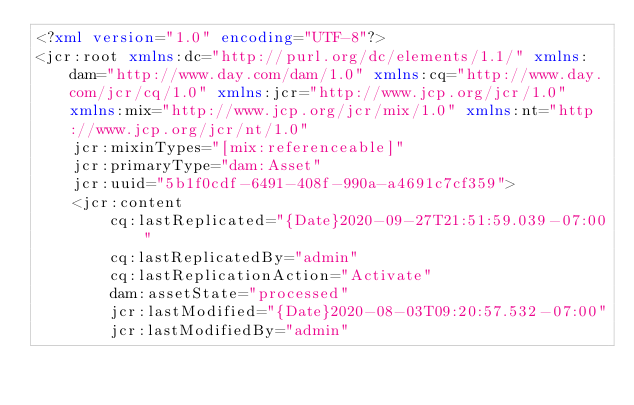<code> <loc_0><loc_0><loc_500><loc_500><_XML_><?xml version="1.0" encoding="UTF-8"?>
<jcr:root xmlns:dc="http://purl.org/dc/elements/1.1/" xmlns:dam="http://www.day.com/dam/1.0" xmlns:cq="http://www.day.com/jcr/cq/1.0" xmlns:jcr="http://www.jcp.org/jcr/1.0" xmlns:mix="http://www.jcp.org/jcr/mix/1.0" xmlns:nt="http://www.jcp.org/jcr/nt/1.0"
    jcr:mixinTypes="[mix:referenceable]"
    jcr:primaryType="dam:Asset"
    jcr:uuid="5b1f0cdf-6491-408f-990a-a4691c7cf359">
    <jcr:content
        cq:lastReplicated="{Date}2020-09-27T21:51:59.039-07:00"
        cq:lastReplicatedBy="admin"
        cq:lastReplicationAction="Activate"
        dam:assetState="processed"
        jcr:lastModified="{Date}2020-08-03T09:20:57.532-07:00"
        jcr:lastModifiedBy="admin"</code> 